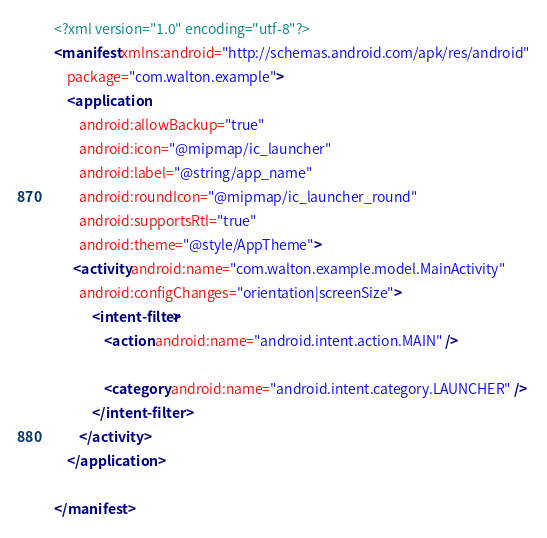Convert code to text. <code><loc_0><loc_0><loc_500><loc_500><_XML_><?xml version="1.0" encoding="utf-8"?>
<manifest xmlns:android="http://schemas.android.com/apk/res/android"
    package="com.walton.example">
    <application
        android:allowBackup="true"
        android:icon="@mipmap/ic_launcher"
        android:label="@string/app_name"
        android:roundIcon="@mipmap/ic_launcher_round"
        android:supportsRtl="true"
        android:theme="@style/AppTheme">
      <activity android:name="com.walton.example.model.MainActivity"
		android:configChanges="orientation|screenSize">
            <intent-filter>
                <action android:name="android.intent.action.MAIN" />

                <category android:name="android.intent.category.LAUNCHER" />
            </intent-filter>
        </activity>
    </application>

</manifest>
</code> 